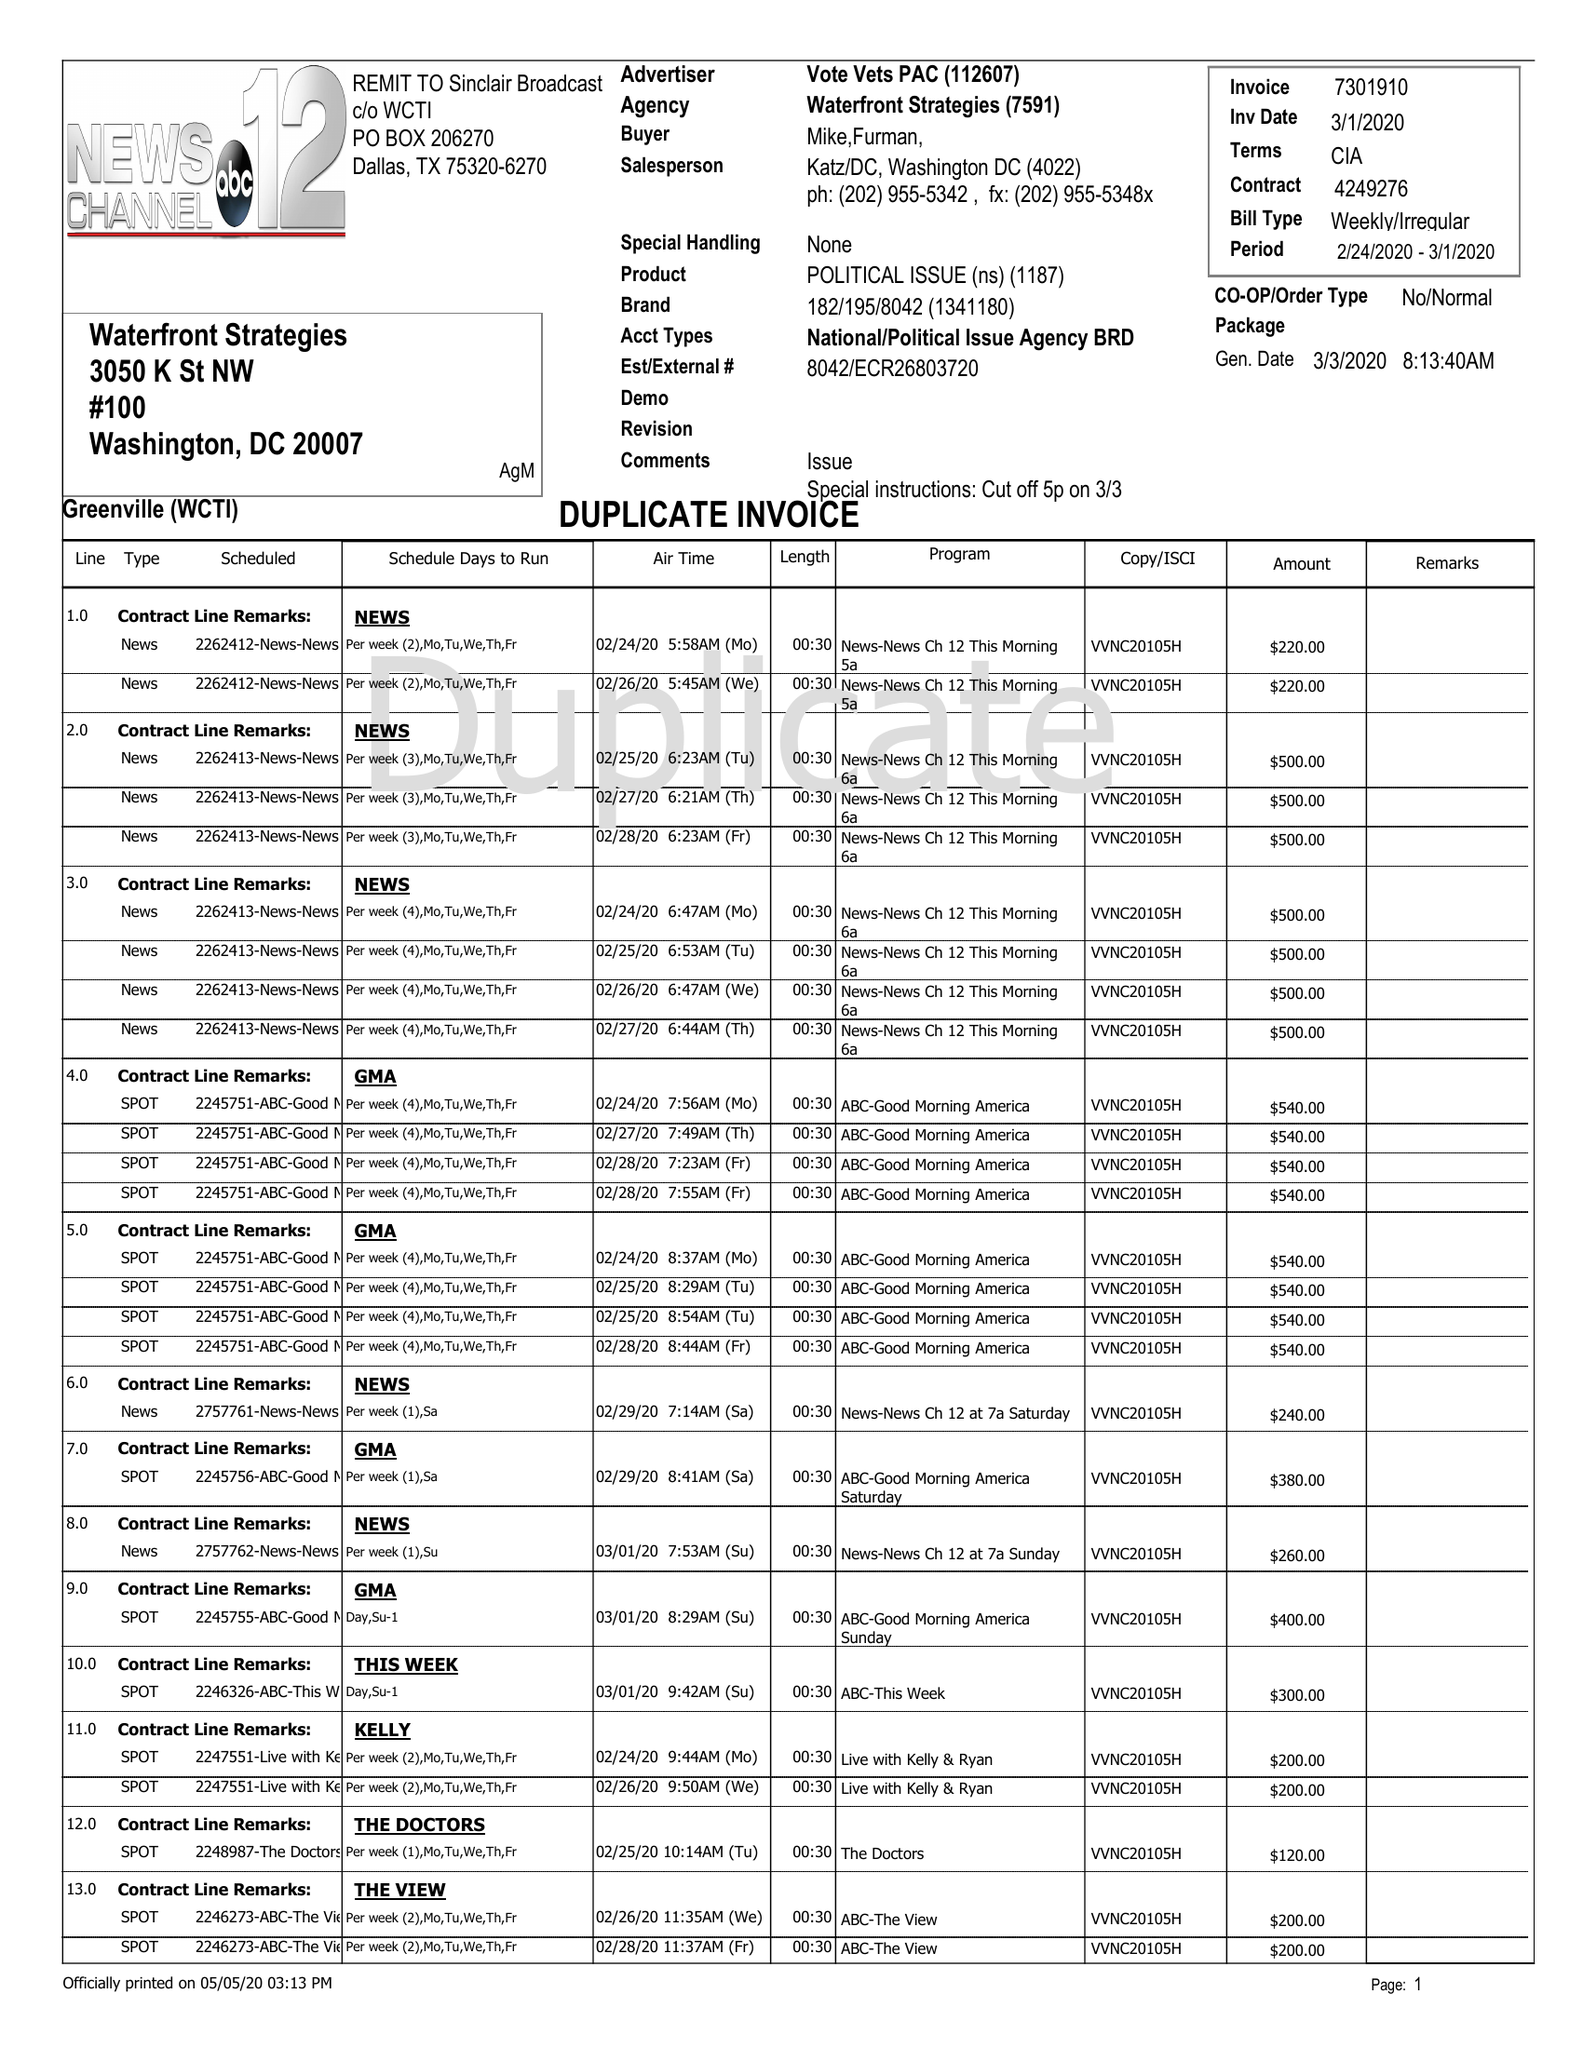What is the value for the contract_num?
Answer the question using a single word or phrase. 4249276 